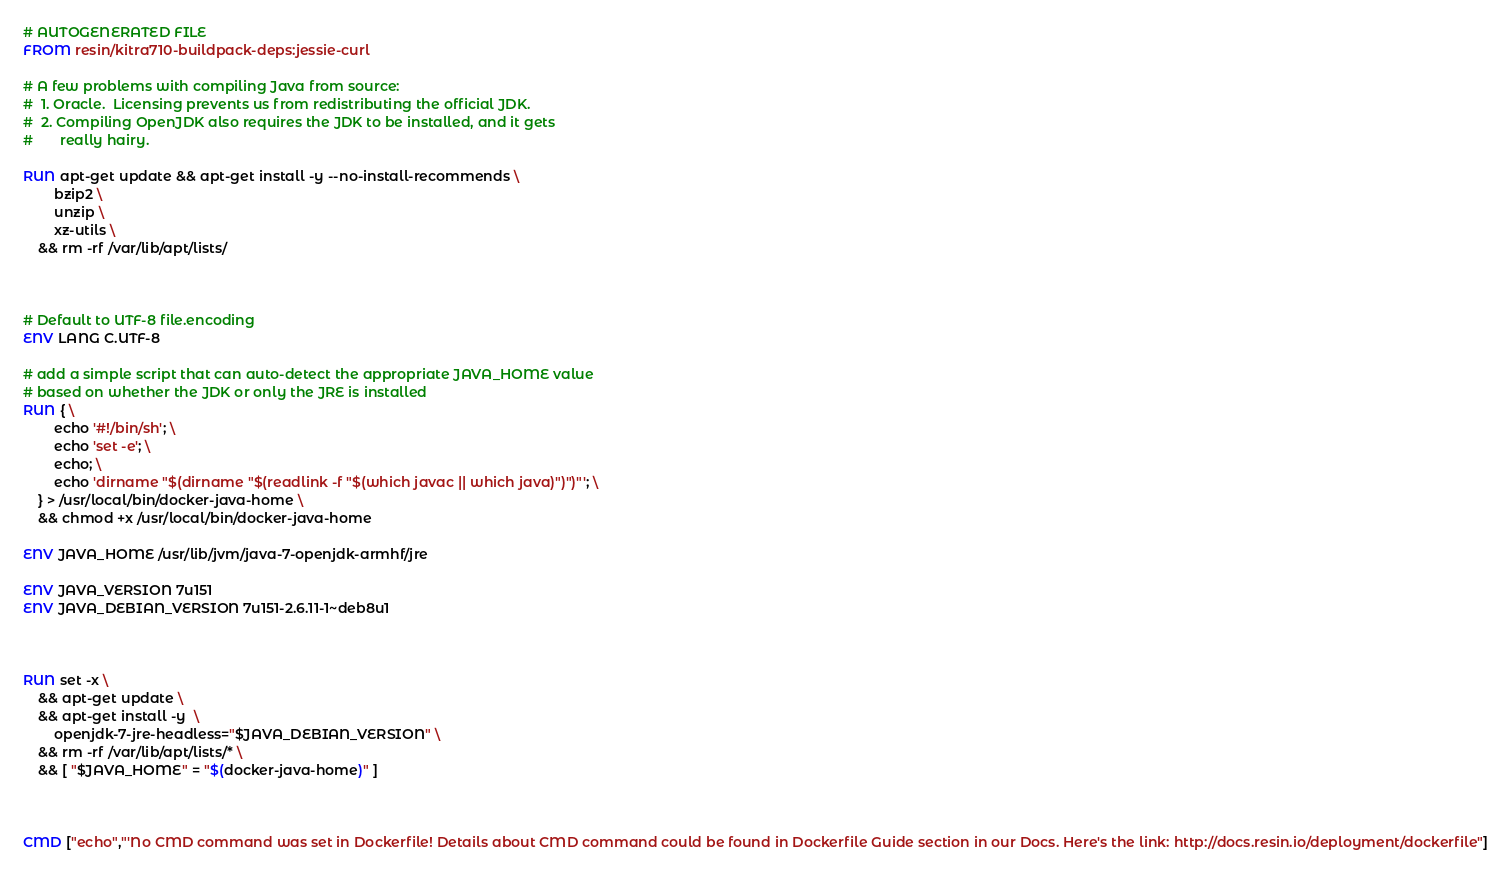<code> <loc_0><loc_0><loc_500><loc_500><_Dockerfile_># AUTOGENERATED FILE
FROM resin/kitra710-buildpack-deps:jessie-curl

# A few problems with compiling Java from source:
#  1. Oracle.  Licensing prevents us from redistributing the official JDK.
#  2. Compiling OpenJDK also requires the JDK to be installed, and it gets
#       really hairy.

RUN apt-get update && apt-get install -y --no-install-recommends \
		bzip2 \
		unzip \
		xz-utils \
	&& rm -rf /var/lib/apt/lists/



# Default to UTF-8 file.encoding
ENV LANG C.UTF-8

# add a simple script that can auto-detect the appropriate JAVA_HOME value
# based on whether the JDK or only the JRE is installed
RUN { \
		echo '#!/bin/sh'; \
		echo 'set -e'; \
		echo; \
		echo 'dirname "$(dirname "$(readlink -f "$(which javac || which java)")")"'; \
	} > /usr/local/bin/docker-java-home \
	&& chmod +x /usr/local/bin/docker-java-home

ENV JAVA_HOME /usr/lib/jvm/java-7-openjdk-armhf/jre

ENV JAVA_VERSION 7u151
ENV JAVA_DEBIAN_VERSION 7u151-2.6.11-1~deb8u1



RUN set -x \
	&& apt-get update \
	&& apt-get install -y  \
		openjdk-7-jre-headless="$JAVA_DEBIAN_VERSION" \
	&& rm -rf /var/lib/apt/lists/* \
	&& [ "$JAVA_HOME" = "$(docker-java-home)" ]



CMD ["echo","'No CMD command was set in Dockerfile! Details about CMD command could be found in Dockerfile Guide section in our Docs. Here's the link: http://docs.resin.io/deployment/dockerfile"]
</code> 